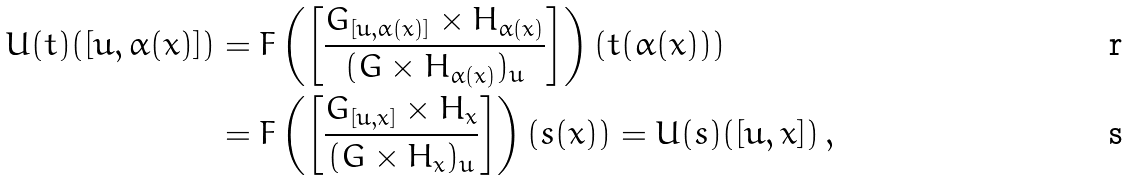Convert formula to latex. <formula><loc_0><loc_0><loc_500><loc_500>U ( t ) ( [ u , \alpha ( x ) ] ) & = F \left ( \left [ \frac { G _ { [ u , \alpha ( x ) ] } \times H _ { \alpha ( x ) } } { ( G \times H _ { \alpha ( x ) } ) _ { u } } \right ] \right ) \left ( t ( \alpha ( x ) ) \right ) \\ & = F \left ( \left [ \frac { G _ { [ u , x ] } \times H _ { x } } { ( G \times H _ { x } ) _ { u } } \right ] \right ) \left ( s ( x ) \right ) = U ( s ) ( [ u , x ] ) \, ,</formula> 